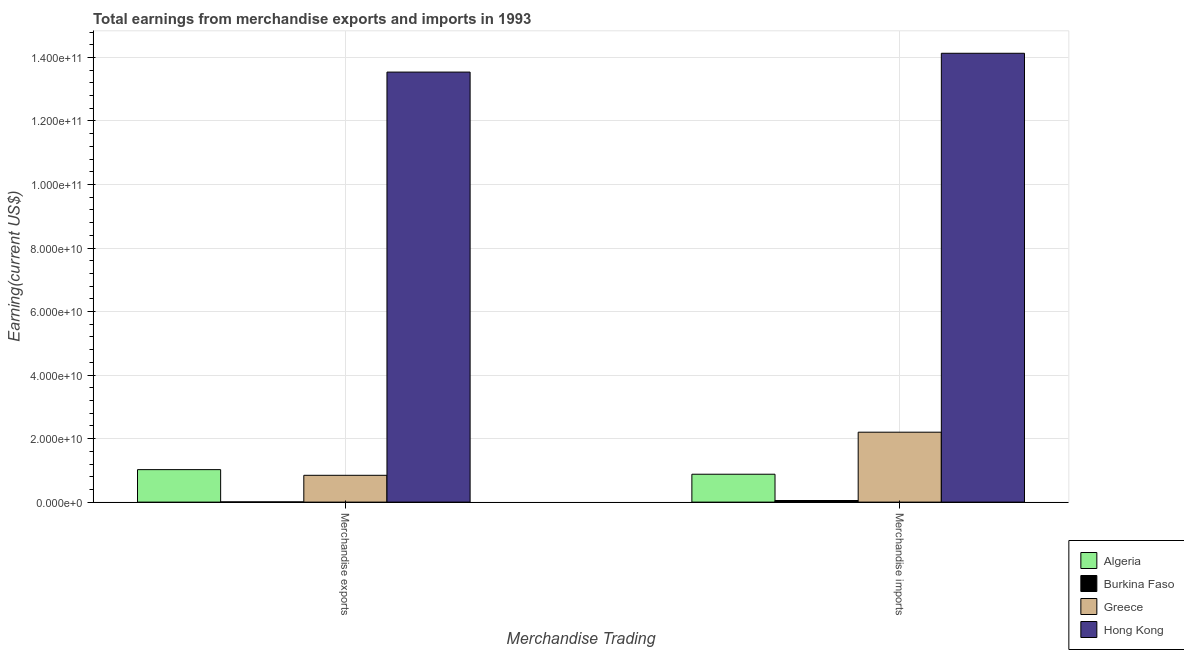How many different coloured bars are there?
Your response must be concise. 4. Are the number of bars per tick equal to the number of legend labels?
Make the answer very short. Yes. Are the number of bars on each tick of the X-axis equal?
Provide a succinct answer. Yes. What is the label of the 2nd group of bars from the left?
Ensure brevity in your answer.  Merchandise imports. What is the earnings from merchandise imports in Hong Kong?
Your response must be concise. 1.41e+11. Across all countries, what is the maximum earnings from merchandise imports?
Provide a succinct answer. 1.41e+11. Across all countries, what is the minimum earnings from merchandise imports?
Ensure brevity in your answer.  5.09e+08. In which country was the earnings from merchandise exports maximum?
Your response must be concise. Hong Kong. In which country was the earnings from merchandise exports minimum?
Your answer should be compact. Burkina Faso. What is the total earnings from merchandise exports in the graph?
Make the answer very short. 1.54e+11. What is the difference between the earnings from merchandise exports in Hong Kong and that in Greece?
Offer a terse response. 1.27e+11. What is the difference between the earnings from merchandise imports in Greece and the earnings from merchandise exports in Hong Kong?
Keep it short and to the point. -1.13e+11. What is the average earnings from merchandise exports per country?
Give a very brief answer. 3.85e+1. What is the difference between the earnings from merchandise imports and earnings from merchandise exports in Algeria?
Your response must be concise. -1.44e+09. In how many countries, is the earnings from merchandise imports greater than 136000000000 US$?
Provide a succinct answer. 1. What is the ratio of the earnings from merchandise imports in Greece to that in Hong Kong?
Your answer should be compact. 0.16. What does the 4th bar from the left in Merchandise imports represents?
Your answer should be compact. Hong Kong. What does the 4th bar from the right in Merchandise exports represents?
Ensure brevity in your answer.  Algeria. How many bars are there?
Give a very brief answer. 8. What is the difference between two consecutive major ticks on the Y-axis?
Your answer should be very brief. 2.00e+1. Does the graph contain grids?
Ensure brevity in your answer.  Yes. Where does the legend appear in the graph?
Provide a succinct answer. Bottom right. What is the title of the graph?
Keep it short and to the point. Total earnings from merchandise exports and imports in 1993. What is the label or title of the X-axis?
Offer a very short reply. Merchandise Trading. What is the label or title of the Y-axis?
Provide a short and direct response. Earning(current US$). What is the Earning(current US$) in Algeria in Merchandise exports?
Provide a short and direct response. 1.02e+1. What is the Earning(current US$) of Burkina Faso in Merchandise exports?
Ensure brevity in your answer.  6.90e+07. What is the Earning(current US$) in Greece in Merchandise exports?
Ensure brevity in your answer.  8.44e+09. What is the Earning(current US$) of Hong Kong in Merchandise exports?
Keep it short and to the point. 1.35e+11. What is the Earning(current US$) of Algeria in Merchandise imports?
Keep it short and to the point. 8.78e+09. What is the Earning(current US$) of Burkina Faso in Merchandise imports?
Give a very brief answer. 5.09e+08. What is the Earning(current US$) of Greece in Merchandise imports?
Give a very brief answer. 2.20e+1. What is the Earning(current US$) of Hong Kong in Merchandise imports?
Your response must be concise. 1.41e+11. Across all Merchandise Trading, what is the maximum Earning(current US$) in Algeria?
Your answer should be compact. 1.02e+1. Across all Merchandise Trading, what is the maximum Earning(current US$) in Burkina Faso?
Offer a terse response. 5.09e+08. Across all Merchandise Trading, what is the maximum Earning(current US$) of Greece?
Give a very brief answer. 2.20e+1. Across all Merchandise Trading, what is the maximum Earning(current US$) of Hong Kong?
Provide a succinct answer. 1.41e+11. Across all Merchandise Trading, what is the minimum Earning(current US$) of Algeria?
Your response must be concise. 8.78e+09. Across all Merchandise Trading, what is the minimum Earning(current US$) of Burkina Faso?
Make the answer very short. 6.90e+07. Across all Merchandise Trading, what is the minimum Earning(current US$) of Greece?
Provide a succinct answer. 8.44e+09. Across all Merchandise Trading, what is the minimum Earning(current US$) of Hong Kong?
Keep it short and to the point. 1.35e+11. What is the total Earning(current US$) of Algeria in the graph?
Ensure brevity in your answer.  1.90e+1. What is the total Earning(current US$) in Burkina Faso in the graph?
Your answer should be very brief. 5.78e+08. What is the total Earning(current US$) of Greece in the graph?
Your answer should be very brief. 3.05e+1. What is the total Earning(current US$) in Hong Kong in the graph?
Ensure brevity in your answer.  2.77e+11. What is the difference between the Earning(current US$) in Algeria in Merchandise exports and that in Merchandise imports?
Make the answer very short. 1.44e+09. What is the difference between the Earning(current US$) of Burkina Faso in Merchandise exports and that in Merchandise imports?
Your answer should be compact. -4.40e+08. What is the difference between the Earning(current US$) in Greece in Merchandise exports and that in Merchandise imports?
Offer a terse response. -1.36e+1. What is the difference between the Earning(current US$) in Hong Kong in Merchandise exports and that in Merchandise imports?
Give a very brief answer. -5.92e+09. What is the difference between the Earning(current US$) of Algeria in Merchandise exports and the Earning(current US$) of Burkina Faso in Merchandise imports?
Your response must be concise. 9.72e+09. What is the difference between the Earning(current US$) of Algeria in Merchandise exports and the Earning(current US$) of Greece in Merchandise imports?
Give a very brief answer. -1.18e+1. What is the difference between the Earning(current US$) in Algeria in Merchandise exports and the Earning(current US$) in Hong Kong in Merchandise imports?
Offer a very short reply. -1.31e+11. What is the difference between the Earning(current US$) in Burkina Faso in Merchandise exports and the Earning(current US$) in Greece in Merchandise imports?
Your response must be concise. -2.19e+1. What is the difference between the Earning(current US$) in Burkina Faso in Merchandise exports and the Earning(current US$) in Hong Kong in Merchandise imports?
Ensure brevity in your answer.  -1.41e+11. What is the difference between the Earning(current US$) of Greece in Merchandise exports and the Earning(current US$) of Hong Kong in Merchandise imports?
Your response must be concise. -1.33e+11. What is the average Earning(current US$) of Algeria per Merchandise Trading?
Make the answer very short. 9.51e+09. What is the average Earning(current US$) in Burkina Faso per Merchandise Trading?
Give a very brief answer. 2.89e+08. What is the average Earning(current US$) of Greece per Merchandise Trading?
Ensure brevity in your answer.  1.52e+1. What is the average Earning(current US$) of Hong Kong per Merchandise Trading?
Your answer should be compact. 1.38e+11. What is the difference between the Earning(current US$) in Algeria and Earning(current US$) in Burkina Faso in Merchandise exports?
Offer a very short reply. 1.02e+1. What is the difference between the Earning(current US$) of Algeria and Earning(current US$) of Greece in Merchandise exports?
Your answer should be very brief. 1.79e+09. What is the difference between the Earning(current US$) of Algeria and Earning(current US$) of Hong Kong in Merchandise exports?
Offer a very short reply. -1.25e+11. What is the difference between the Earning(current US$) of Burkina Faso and Earning(current US$) of Greece in Merchandise exports?
Provide a short and direct response. -8.37e+09. What is the difference between the Earning(current US$) in Burkina Faso and Earning(current US$) in Hong Kong in Merchandise exports?
Your answer should be very brief. -1.35e+11. What is the difference between the Earning(current US$) in Greece and Earning(current US$) in Hong Kong in Merchandise exports?
Keep it short and to the point. -1.27e+11. What is the difference between the Earning(current US$) in Algeria and Earning(current US$) in Burkina Faso in Merchandise imports?
Provide a succinct answer. 8.28e+09. What is the difference between the Earning(current US$) in Algeria and Earning(current US$) in Greece in Merchandise imports?
Give a very brief answer. -1.32e+1. What is the difference between the Earning(current US$) in Algeria and Earning(current US$) in Hong Kong in Merchandise imports?
Offer a terse response. -1.33e+11. What is the difference between the Earning(current US$) in Burkina Faso and Earning(current US$) in Greece in Merchandise imports?
Your answer should be very brief. -2.15e+1. What is the difference between the Earning(current US$) of Burkina Faso and Earning(current US$) of Hong Kong in Merchandise imports?
Give a very brief answer. -1.41e+11. What is the difference between the Earning(current US$) of Greece and Earning(current US$) of Hong Kong in Merchandise imports?
Make the answer very short. -1.19e+11. What is the ratio of the Earning(current US$) in Algeria in Merchandise exports to that in Merchandise imports?
Your answer should be very brief. 1.16. What is the ratio of the Earning(current US$) in Burkina Faso in Merchandise exports to that in Merchandise imports?
Provide a succinct answer. 0.14. What is the ratio of the Earning(current US$) in Greece in Merchandise exports to that in Merchandise imports?
Provide a short and direct response. 0.38. What is the ratio of the Earning(current US$) in Hong Kong in Merchandise exports to that in Merchandise imports?
Keep it short and to the point. 0.96. What is the difference between the highest and the second highest Earning(current US$) in Algeria?
Provide a short and direct response. 1.44e+09. What is the difference between the highest and the second highest Earning(current US$) in Burkina Faso?
Your answer should be very brief. 4.40e+08. What is the difference between the highest and the second highest Earning(current US$) in Greece?
Ensure brevity in your answer.  1.36e+1. What is the difference between the highest and the second highest Earning(current US$) of Hong Kong?
Make the answer very short. 5.92e+09. What is the difference between the highest and the lowest Earning(current US$) of Algeria?
Offer a very short reply. 1.44e+09. What is the difference between the highest and the lowest Earning(current US$) of Burkina Faso?
Ensure brevity in your answer.  4.40e+08. What is the difference between the highest and the lowest Earning(current US$) in Greece?
Keep it short and to the point. 1.36e+1. What is the difference between the highest and the lowest Earning(current US$) of Hong Kong?
Ensure brevity in your answer.  5.92e+09. 